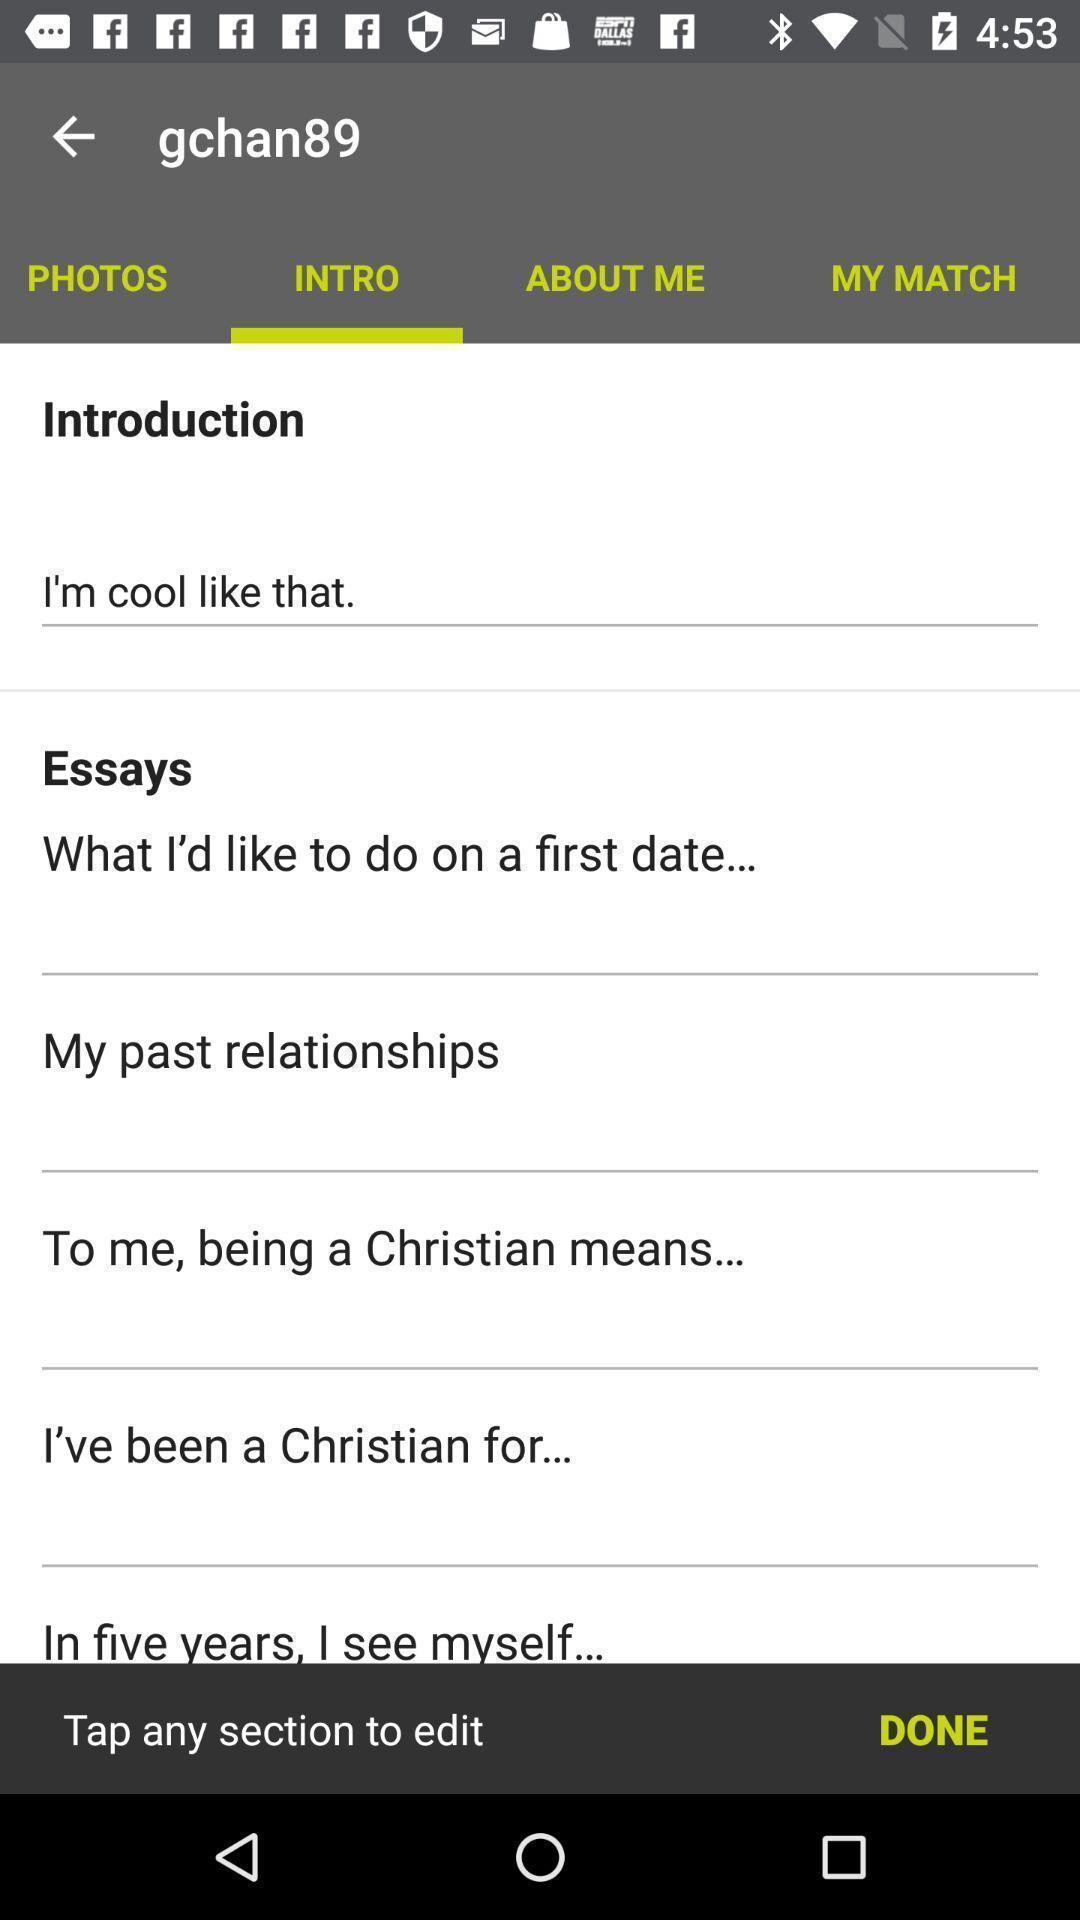Explain what's happening in this screen capture. Screen displaying multiple options in a dating application. 